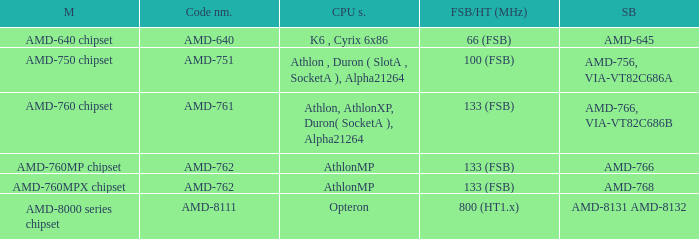What is the fsb / ht (mhz) when the southbridge is amd-8131 amd-8132? 800 (HT1.x). 